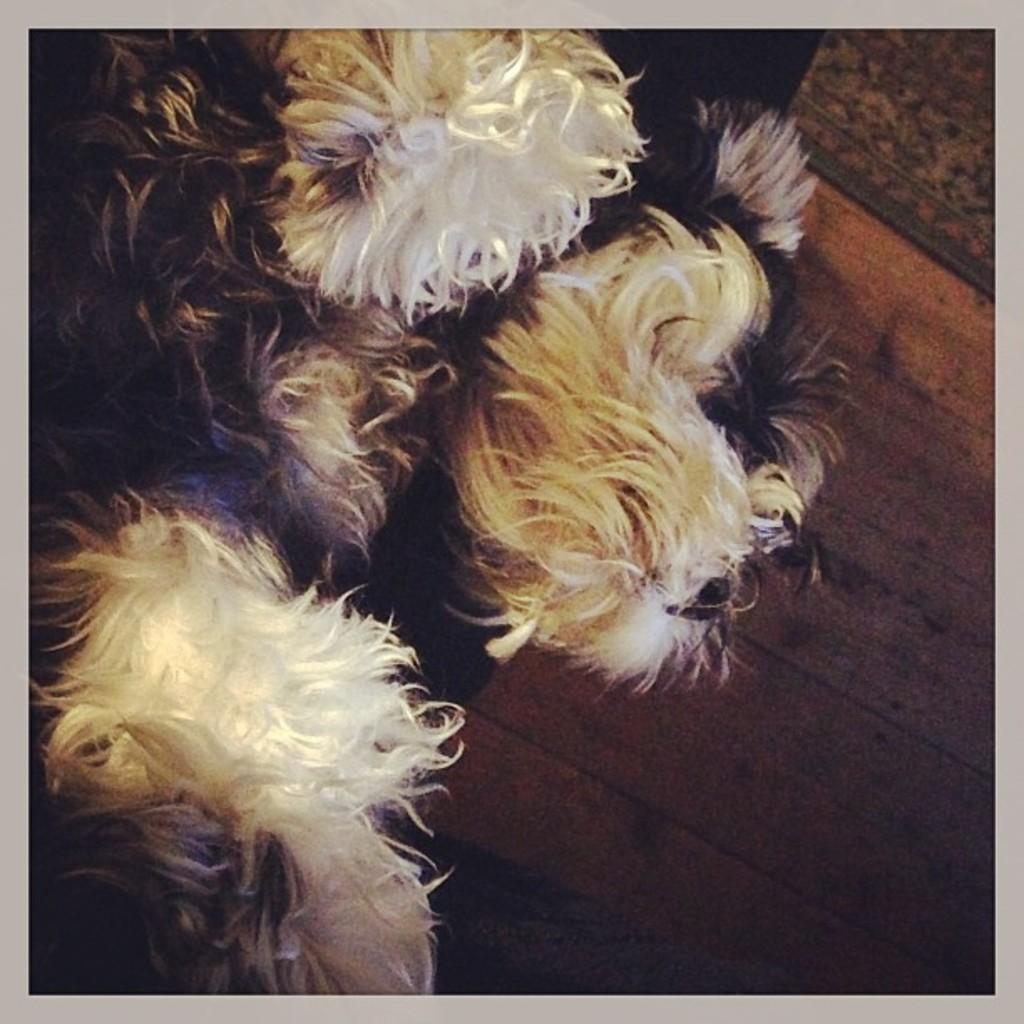How would you summarize this image in a sentence or two? In this picture we can see a dog on the wooden floor. 